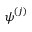Convert formula to latex. <formula><loc_0><loc_0><loc_500><loc_500>\psi ^ { ( j ) }</formula> 